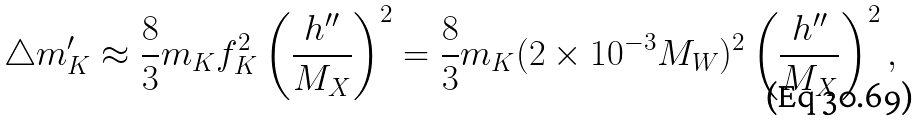<formula> <loc_0><loc_0><loc_500><loc_500>\triangle m ^ { \prime } _ { K } \approx \frac { 8 } { 3 } m _ { K } f ^ { 2 } _ { K } \left ( \frac { h ^ { \prime \prime } } { M _ { X } } \right ) ^ { 2 } = \frac { 8 } { 3 } m _ { K } ( 2 \times 1 0 ^ { - 3 } M _ { W } ) ^ { 2 } \left ( \frac { h ^ { \prime \prime } } { M _ { X } } \right ) ^ { 2 } ,</formula> 